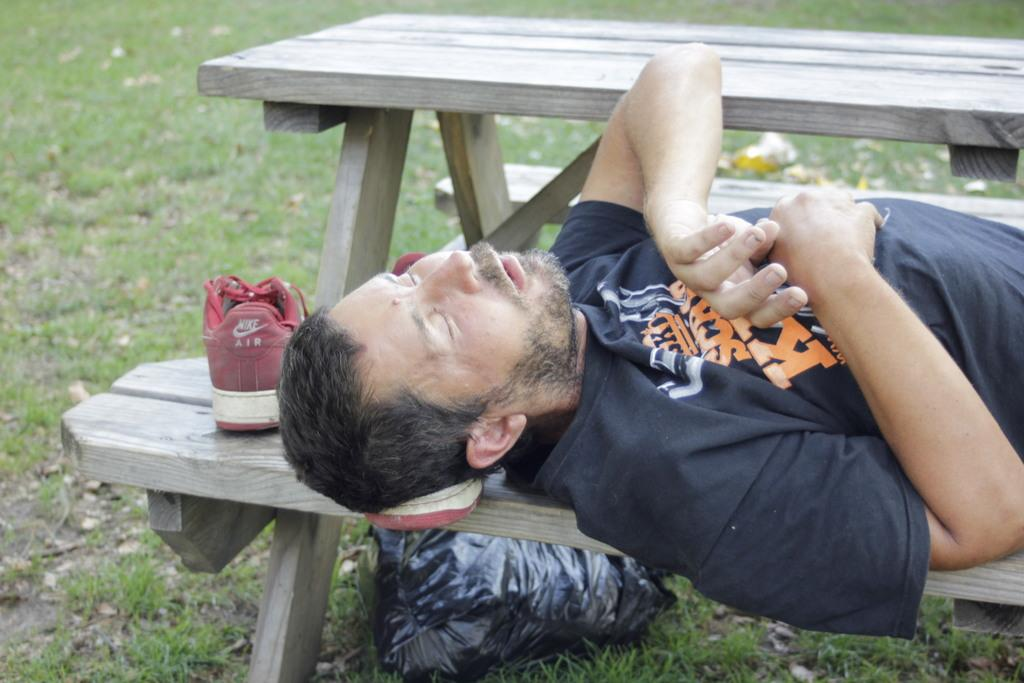Who is the main subject in the image? There is a man in the image. What is the man's position in the image? The man is lying on a wooden table. Are there any objects near the man in the image? Yes, there is a shoe beside the man's head. What type of nerve is being stimulated by the planes in the image? There are no planes present in the image, and therefore no nerve stimulation can be observed. 